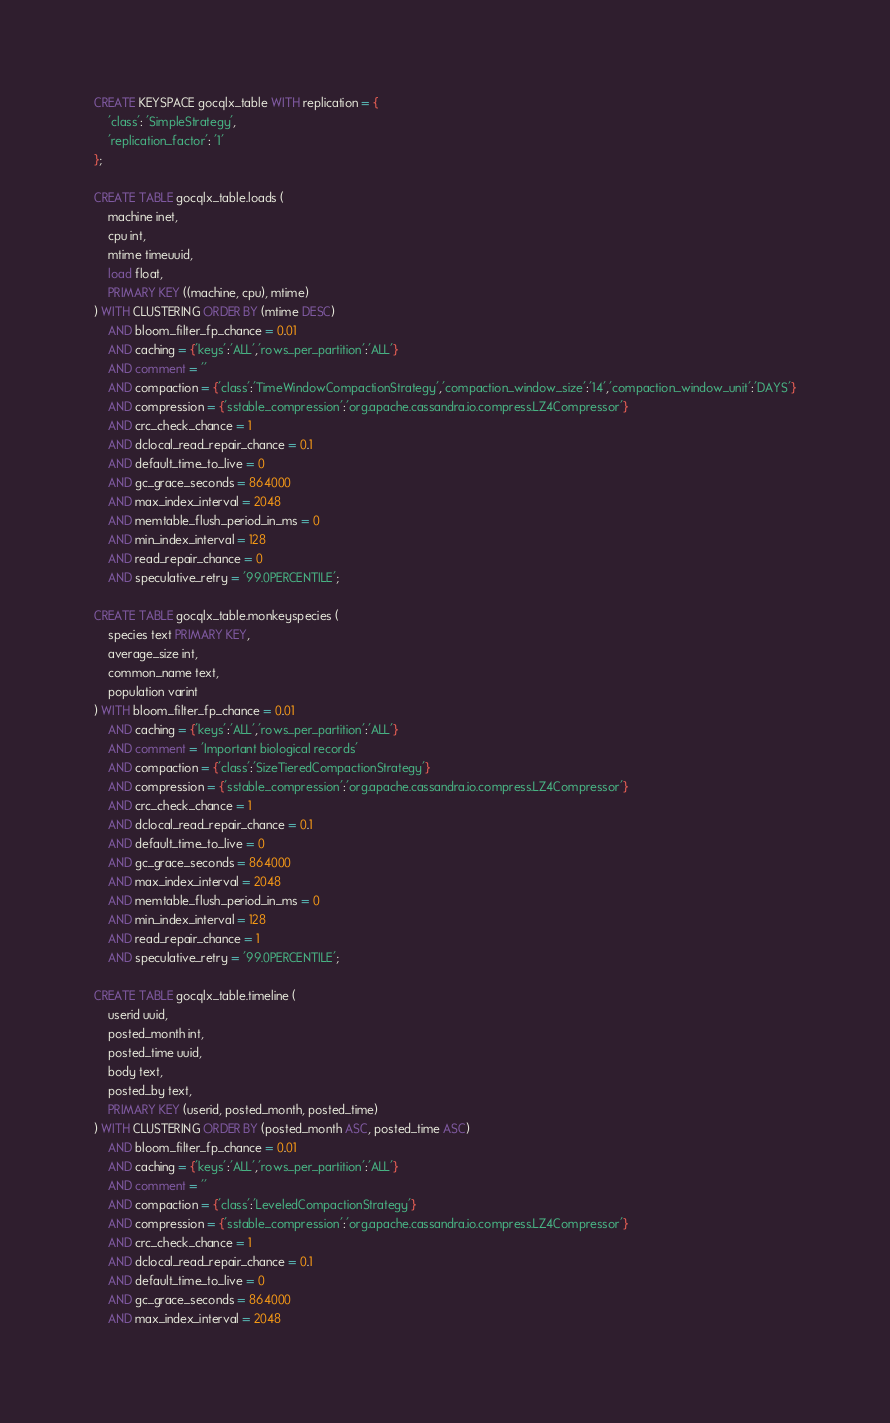Convert code to text. <code><loc_0><loc_0><loc_500><loc_500><_SQL_>CREATE KEYSPACE gocqlx_table WITH replication = {
    'class': 'SimpleStrategy',
    'replication_factor': '1'
};

CREATE TABLE gocqlx_table.loads (
    machine inet,
    cpu int,
    mtime timeuuid,
    load float,
    PRIMARY KEY ((machine, cpu), mtime)
) WITH CLUSTERING ORDER BY (mtime DESC)
    AND bloom_filter_fp_chance = 0.01
    AND caching = {'keys':'ALL','rows_per_partition':'ALL'}
    AND comment = ''
    AND compaction = {'class':'TimeWindowCompactionStrategy','compaction_window_size':'14','compaction_window_unit':'DAYS'}
    AND compression = {'sstable_compression':'org.apache.cassandra.io.compress.LZ4Compressor'}
    AND crc_check_chance = 1
    AND dclocal_read_repair_chance = 0.1
    AND default_time_to_live = 0
    AND gc_grace_seconds = 864000
    AND max_index_interval = 2048
    AND memtable_flush_period_in_ms = 0
    AND min_index_interval = 128
    AND read_repair_chance = 0
    AND speculative_retry = '99.0PERCENTILE';

CREATE TABLE gocqlx_table.monkeyspecies (
    species text PRIMARY KEY,
    average_size int,
    common_name text,
    population varint
) WITH bloom_filter_fp_chance = 0.01
    AND caching = {'keys':'ALL','rows_per_partition':'ALL'}
    AND comment = 'Important biological records'
    AND compaction = {'class':'SizeTieredCompactionStrategy'}
    AND compression = {'sstable_compression':'org.apache.cassandra.io.compress.LZ4Compressor'}
    AND crc_check_chance = 1
    AND dclocal_read_repair_chance = 0.1
    AND default_time_to_live = 0
    AND gc_grace_seconds = 864000
    AND max_index_interval = 2048
    AND memtable_flush_period_in_ms = 0
    AND min_index_interval = 128
    AND read_repair_chance = 1
    AND speculative_retry = '99.0PERCENTILE';

CREATE TABLE gocqlx_table.timeline (
    userid uuid,
    posted_month int,
    posted_time uuid,
    body text,
    posted_by text,
    PRIMARY KEY (userid, posted_month, posted_time)
) WITH CLUSTERING ORDER BY (posted_month ASC, posted_time ASC)
    AND bloom_filter_fp_chance = 0.01
    AND caching = {'keys':'ALL','rows_per_partition':'ALL'}
    AND comment = ''
    AND compaction = {'class':'LeveledCompactionStrategy'}
    AND compression = {'sstable_compression':'org.apache.cassandra.io.compress.LZ4Compressor'}
    AND crc_check_chance = 1
    AND dclocal_read_repair_chance = 0.1
    AND default_time_to_live = 0
    AND gc_grace_seconds = 864000
    AND max_index_interval = 2048</code> 